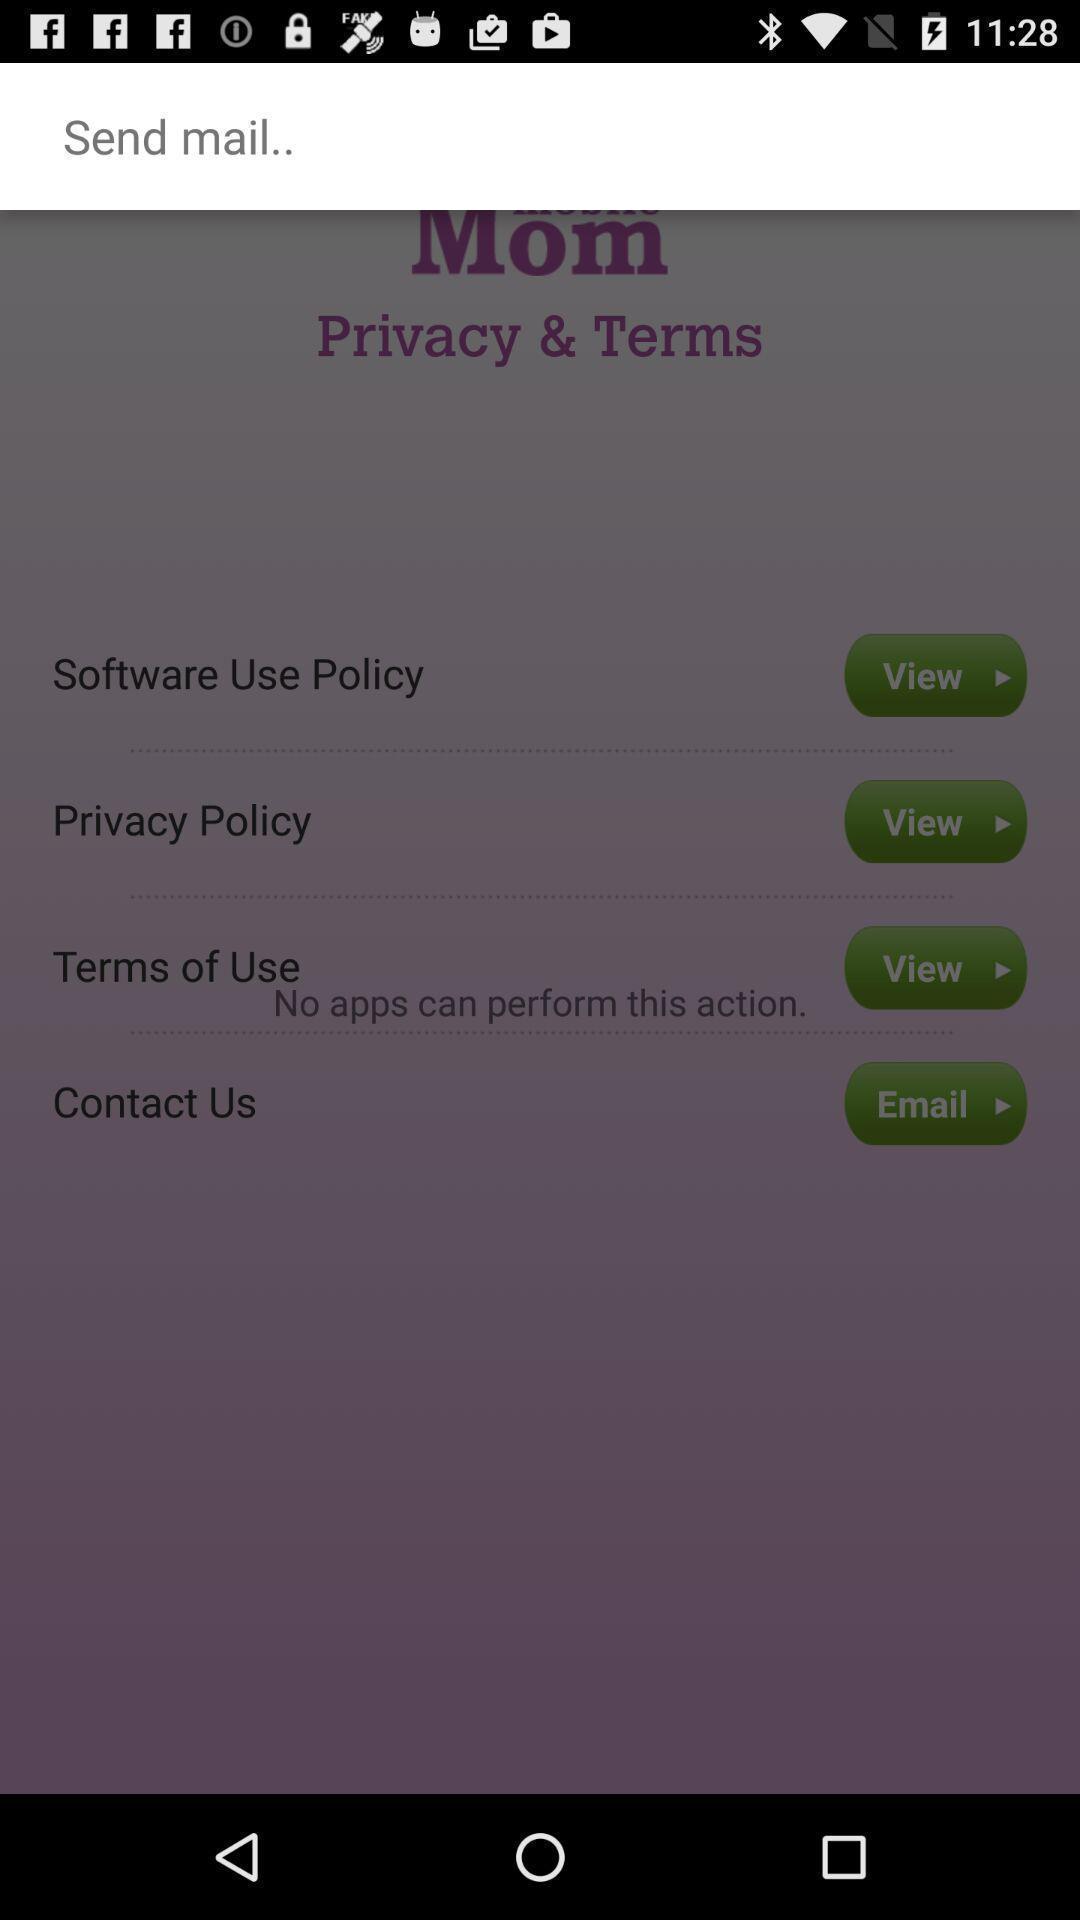What is the overall content of this screenshot? Send a mail of mom privacy and terms. 